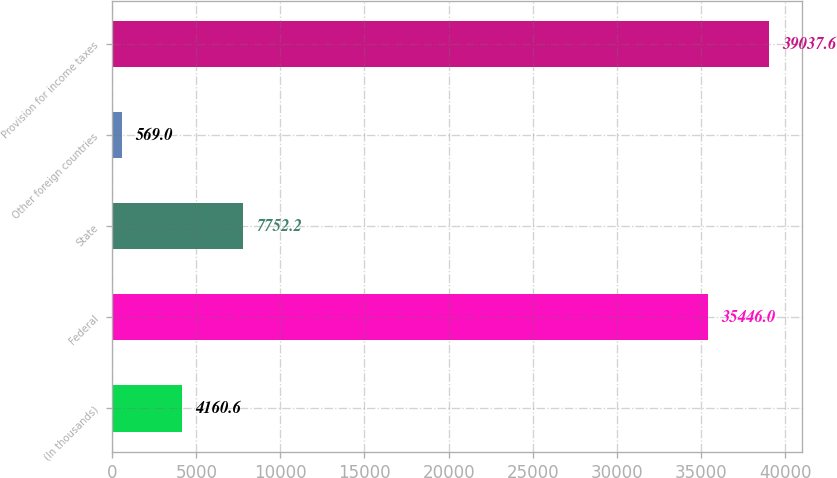Convert chart. <chart><loc_0><loc_0><loc_500><loc_500><bar_chart><fcel>(In thousands)<fcel>Federal<fcel>State<fcel>Other foreign countries<fcel>Provision for income taxes<nl><fcel>4160.6<fcel>35446<fcel>7752.2<fcel>569<fcel>39037.6<nl></chart> 